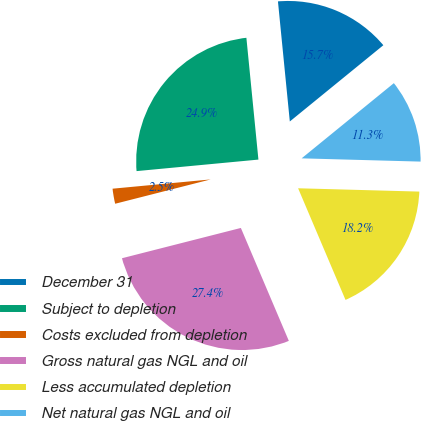<chart> <loc_0><loc_0><loc_500><loc_500><pie_chart><fcel>December 31<fcel>Subject to depletion<fcel>Costs excluded from depletion<fcel>Gross natural gas NGL and oil<fcel>Less accumulated depletion<fcel>Net natural gas NGL and oil<nl><fcel>15.68%<fcel>24.93%<fcel>2.47%<fcel>27.42%<fcel>18.17%<fcel>11.32%<nl></chart> 